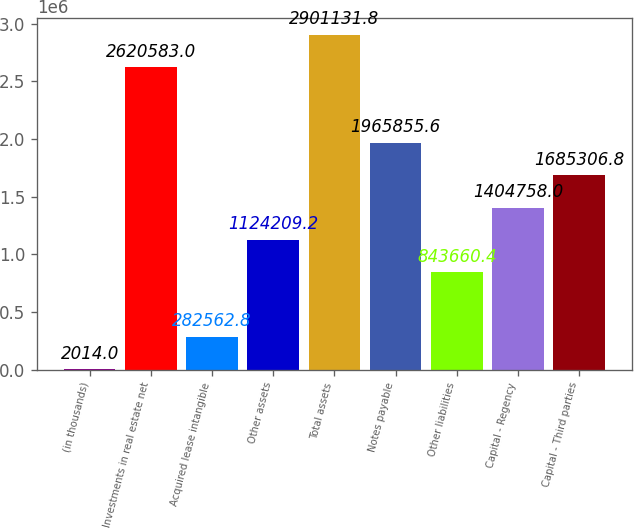Convert chart. <chart><loc_0><loc_0><loc_500><loc_500><bar_chart><fcel>(in thousands)<fcel>Investments in real estate net<fcel>Acquired lease intangible<fcel>Other assets<fcel>Total assets<fcel>Notes payable<fcel>Other liabilities<fcel>Capital - Regency<fcel>Capital - Third parties<nl><fcel>2014<fcel>2.62058e+06<fcel>282563<fcel>1.12421e+06<fcel>2.90113e+06<fcel>1.96586e+06<fcel>843660<fcel>1.40476e+06<fcel>1.68531e+06<nl></chart> 